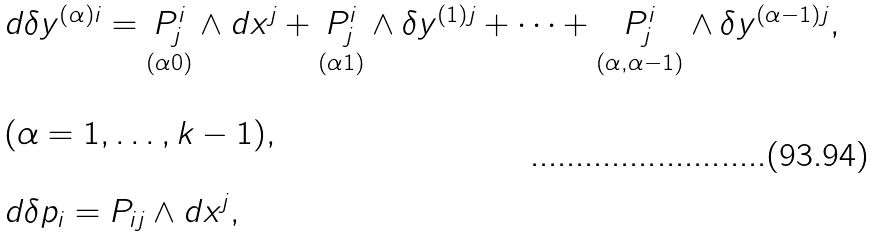<formula> <loc_0><loc_0><loc_500><loc_500>\begin{array} { l } d \delta y ^ { \left ( \alpha \right ) i } = \underset { ( \alpha 0 ) } { P _ { j } ^ { i } } \wedge d x ^ { j } + \underset { ( \alpha 1 ) } { P _ { j } ^ { i } } \wedge \delta y ^ { \left ( 1 \right ) j } + \dots + \underset { ( \alpha , \alpha - 1 ) } { P _ { j } ^ { i } } \wedge \delta y ^ { \left ( \alpha - 1 \right ) j } , \\ \\ ( \alpha = 1 , \dots , k - 1 ) , \\ \\ d \delta p _ { i } = P _ { i j } \wedge d x ^ { j } , \end{array}</formula> 